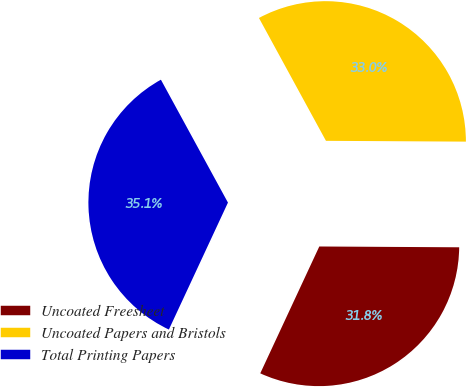Convert chart to OTSL. <chart><loc_0><loc_0><loc_500><loc_500><pie_chart><fcel>Uncoated Freesheet<fcel>Uncoated Papers and Bristols<fcel>Total Printing Papers<nl><fcel>31.84%<fcel>33.04%<fcel>35.12%<nl></chart> 